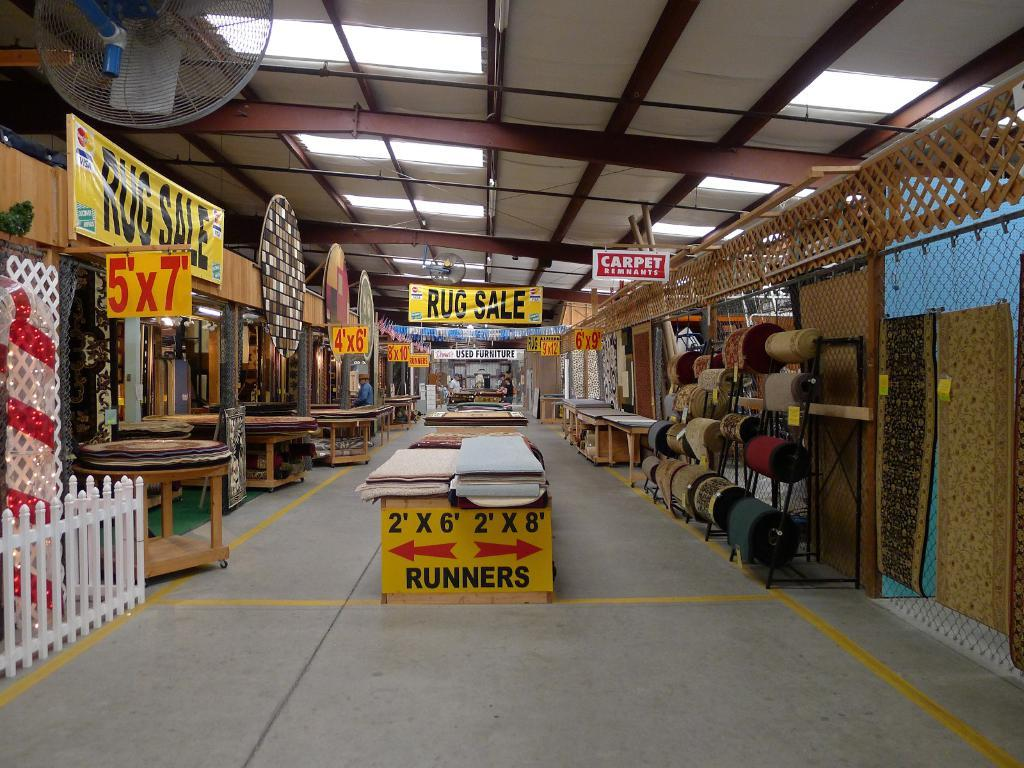<image>
Write a terse but informative summary of the picture. An empty rug store with banners about rug sale. 